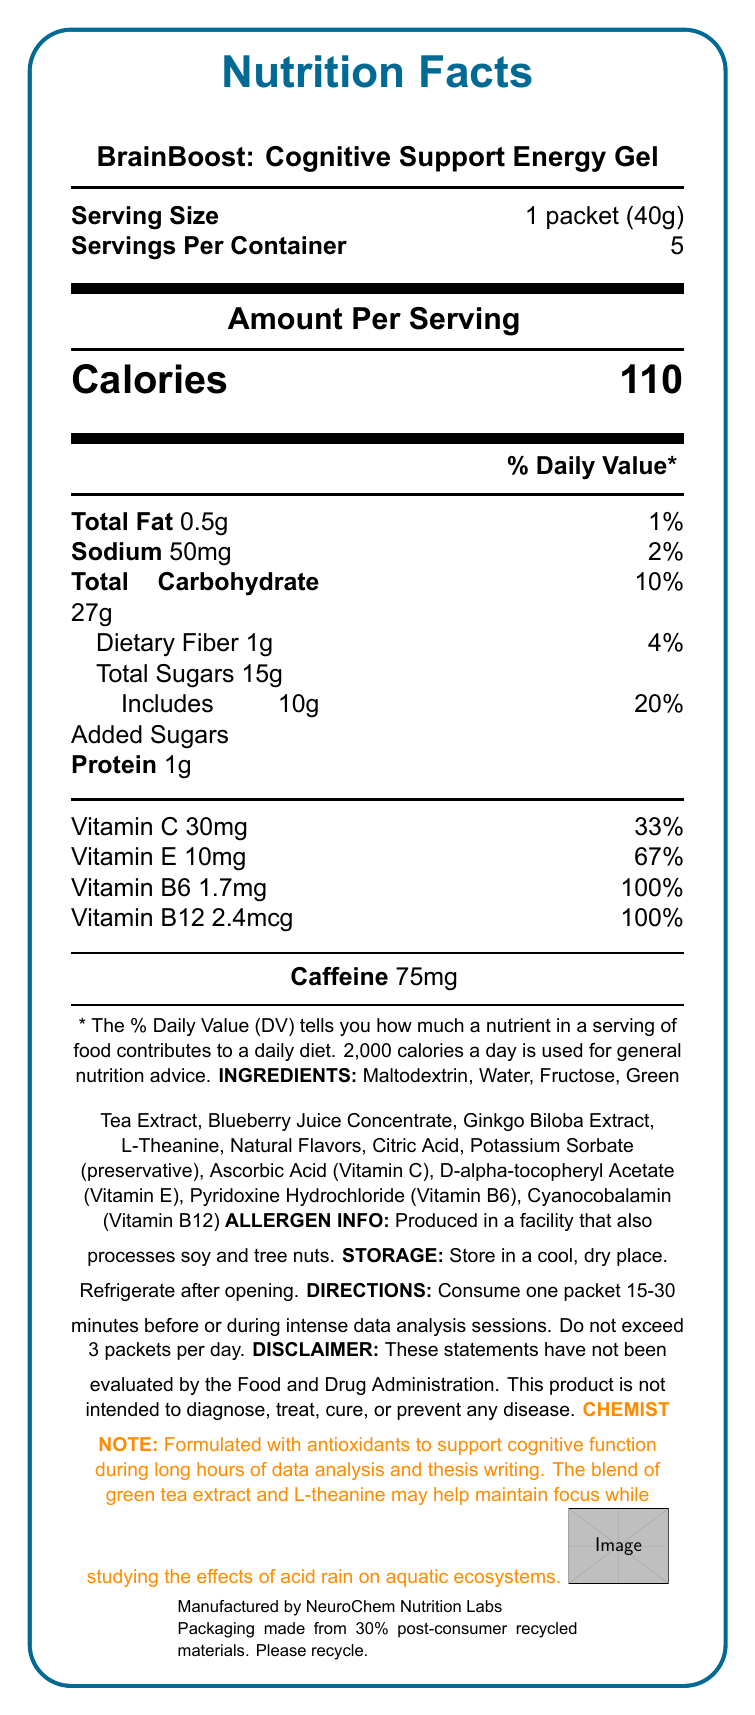what is the serving size? The serving size is stated as "1 packet (40g)" in the Nutrition Facts Label.
Answer: 1 packet (40g) how many servings are in a container? The document specifies "Servings Per Container: 5".
Answer: 5 what is the calorie content per serving? The calorie content is listed as "Calories: 110" per serving.
Answer: 110 calories what is the amount of caffeine per serving? The amount of caffeine is given as 75mg in the document.
Answer: 75mg which vitamins are present in the energy gel? The document lists the vitamins as Vitamin C (30mg), Vitamin E (10mg), Vitamin B6 (1.7mg), and Vitamin B12 (2.4mcg).
Answer: Vitamins C, E, B6, and B12 what should you do after opening the packet? The storage instructions state "Refrigerate after opening".
Answer: Refrigerate what is the daily value percentage of vitamin B6 per serving? A. 50% B. 100% C. 67% The daily value percentage for vitamin B6 per serving is listed as 100% in the document.
Answer: B. 100% which of the following ingredients is not in the energy gel? A. Maltodextrin B. Honey C. Blueberry Juice Concentrate Honey is not listed among the ingredients, while Maltodextrin and Blueberry Juice Concentrate are.
Answer: B. Honey is the product intended to diagnose, treat, cure, or prevent any disease? The disclaimer states that "This product is not intended to diagnose, treat, cure, or prevent any disease."
Answer: No does the product contain gluten? The document does not provide information on gluten content.
Answer: Cannot be determined summarize the entire document The summary should encapsulate all key aspects described in the Nutrition Facts Label, including product purpose, nutritional content, storage instructions, usage directions, manufacturer information, and allergen information.
Answer: BrainBoost: Cognitive Support Energy Gel is an antioxidant-rich supplement designed to support cognitive function during data analysis sessions. Each packet has 110 calories and contains vitamins C, E, B6, and B12, as well as 75mg of caffeine. It should be refrigerated after opening, and it is recommended not to exceed three packets per day. The product is manufactured by NeuroChem Nutrition Labs and is noted for its eco-friendly packaging. It is produced in a facility that processes soy and tree nuts. 